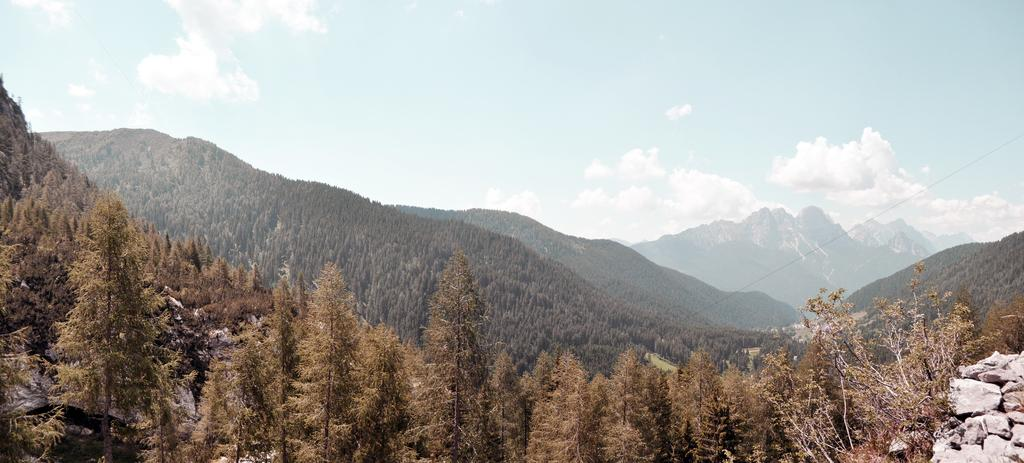What type of vegetation is present in the image? There are many tall trees in the image. What natural feature can be seen behind the trees in the image? There are huge mountains behind the trees in the image. What type of reaction can be seen happening to the coal in the image? There is no coal present in the image; it features tall trees and huge mountains. How many basketballs can be seen in the image? There are no basketballs present in the image. 